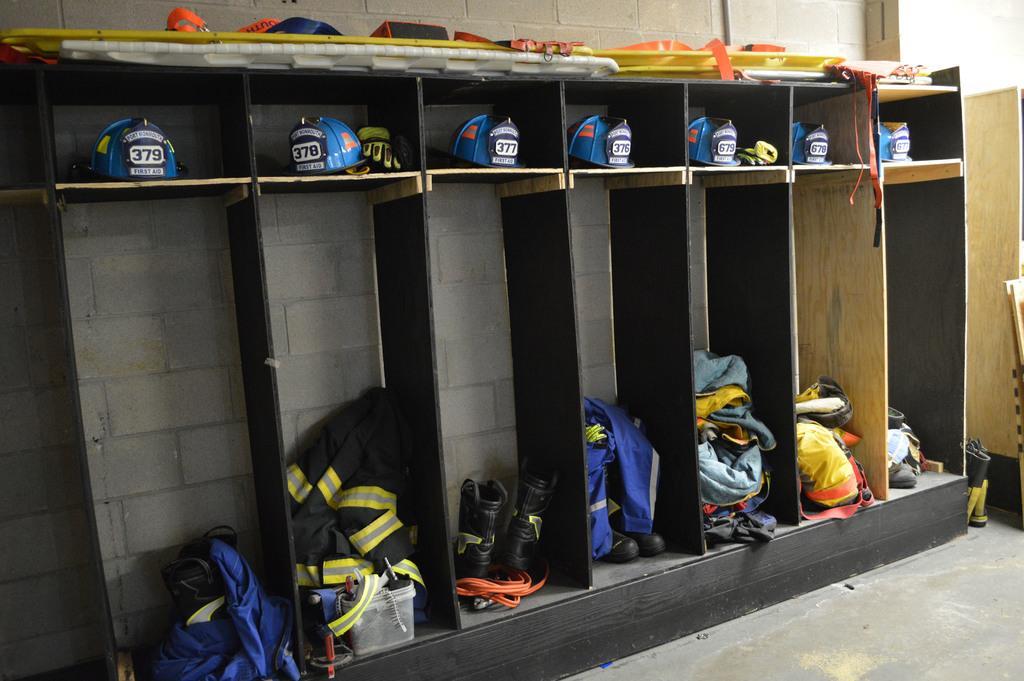Please provide a concise description of this image. This image consists of cupboards. In which there are helmets and clothes along with shoes are kept. At the bottom, there is a floor. In the background, there is a wall. 